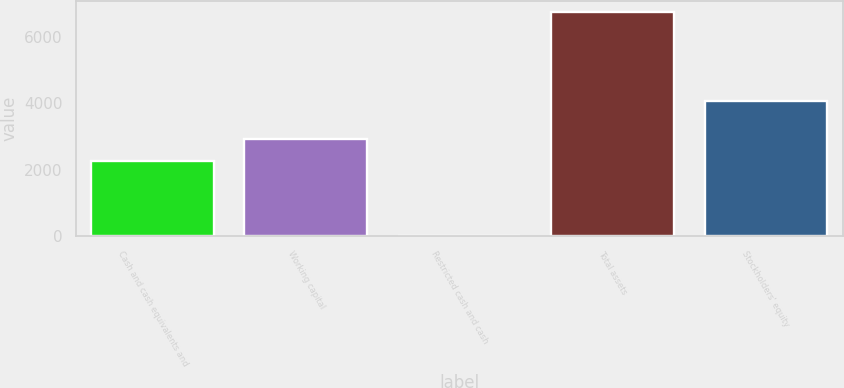Convert chart to OTSL. <chart><loc_0><loc_0><loc_500><loc_500><bar_chart><fcel>Cash and cash equivalents and<fcel>Working capital<fcel>Restricted cash and cash<fcel>Total assets<fcel>Stockholders' equity<nl><fcel>2251<fcel>2923.9<fcel>22<fcel>6751<fcel>4081<nl></chart> 